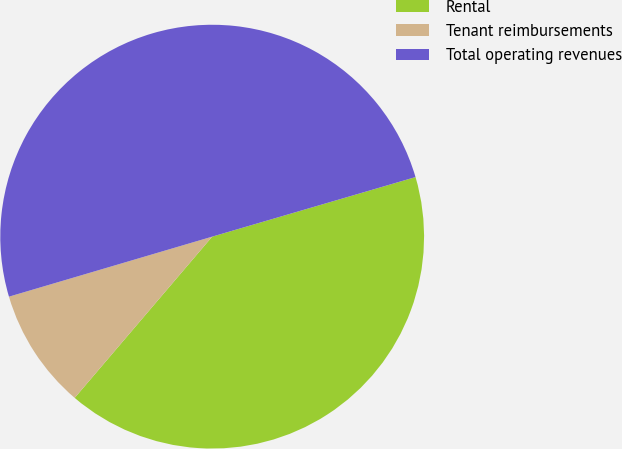Convert chart to OTSL. <chart><loc_0><loc_0><loc_500><loc_500><pie_chart><fcel>Rental<fcel>Tenant reimbursements<fcel>Total operating revenues<nl><fcel>40.77%<fcel>9.19%<fcel>50.03%<nl></chart> 